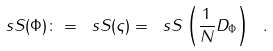<formula> <loc_0><loc_0><loc_500><loc_500>\ s S ( \Phi ) \colon = \ s S ( \varsigma ) = \ s S \left ( { \frac { 1 } { N } } D _ { \Phi } \right ) \ .</formula> 